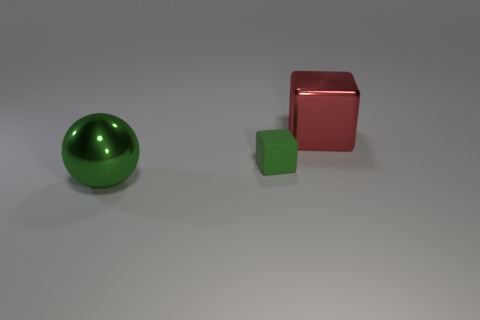How many other things are there of the same size as the red cube?
Give a very brief answer. 1. There is a tiny matte cube; how many large metallic blocks are to the right of it?
Your response must be concise. 1. The green shiny thing is what size?
Provide a succinct answer. Large. Is the material of the thing that is in front of the small green matte block the same as the big thing to the right of the small green rubber thing?
Offer a very short reply. Yes. Is there a shiny thing of the same color as the large cube?
Offer a terse response. No. What color is the shiny object that is the same size as the metallic sphere?
Make the answer very short. Red. Does the large thing that is to the left of the large red cube have the same color as the large cube?
Your answer should be compact. No. Are there any brown cylinders made of the same material as the red cube?
Ensure brevity in your answer.  No. The metal thing that is the same color as the tiny rubber thing is what shape?
Ensure brevity in your answer.  Sphere. Is the number of small cubes behind the tiny green thing less than the number of tiny gray matte objects?
Provide a short and direct response. No. 